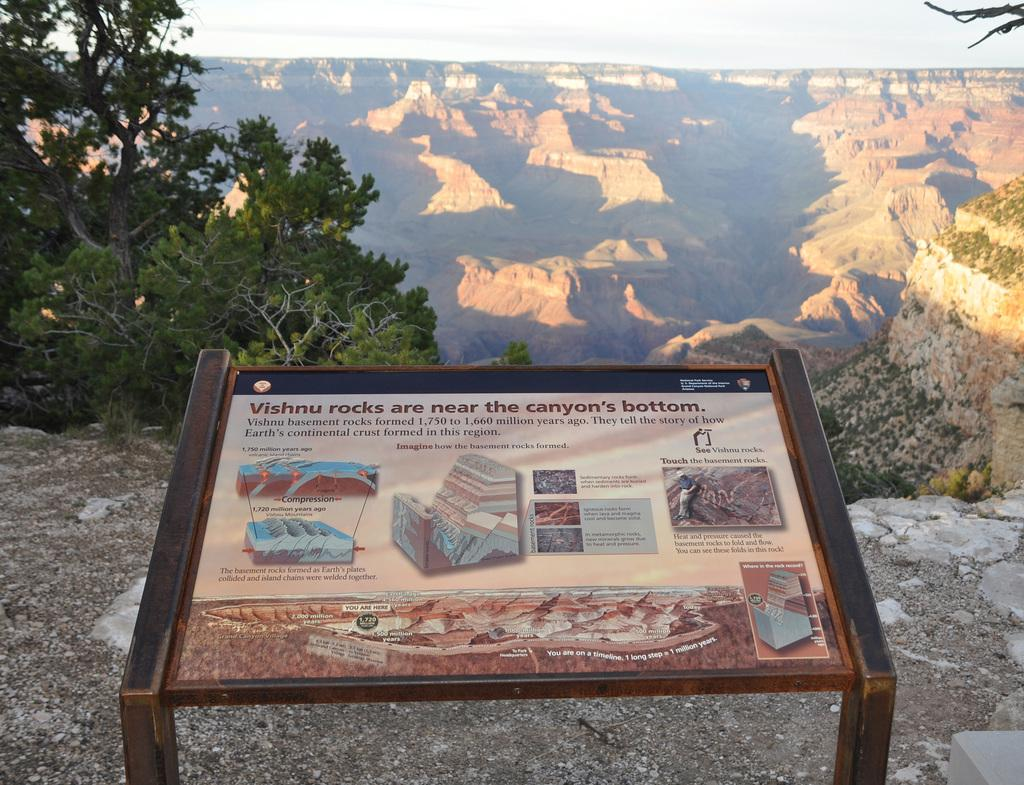What is the main object in the center of the image? There is a board in the center of the image. What can be seen in the background of the image? There are trees and rocks in the background of the image. What is visible above the trees and rocks in the image? The sky is visible in the background of the image. What type of ray is visible in the image? There is no ray present in the image. 